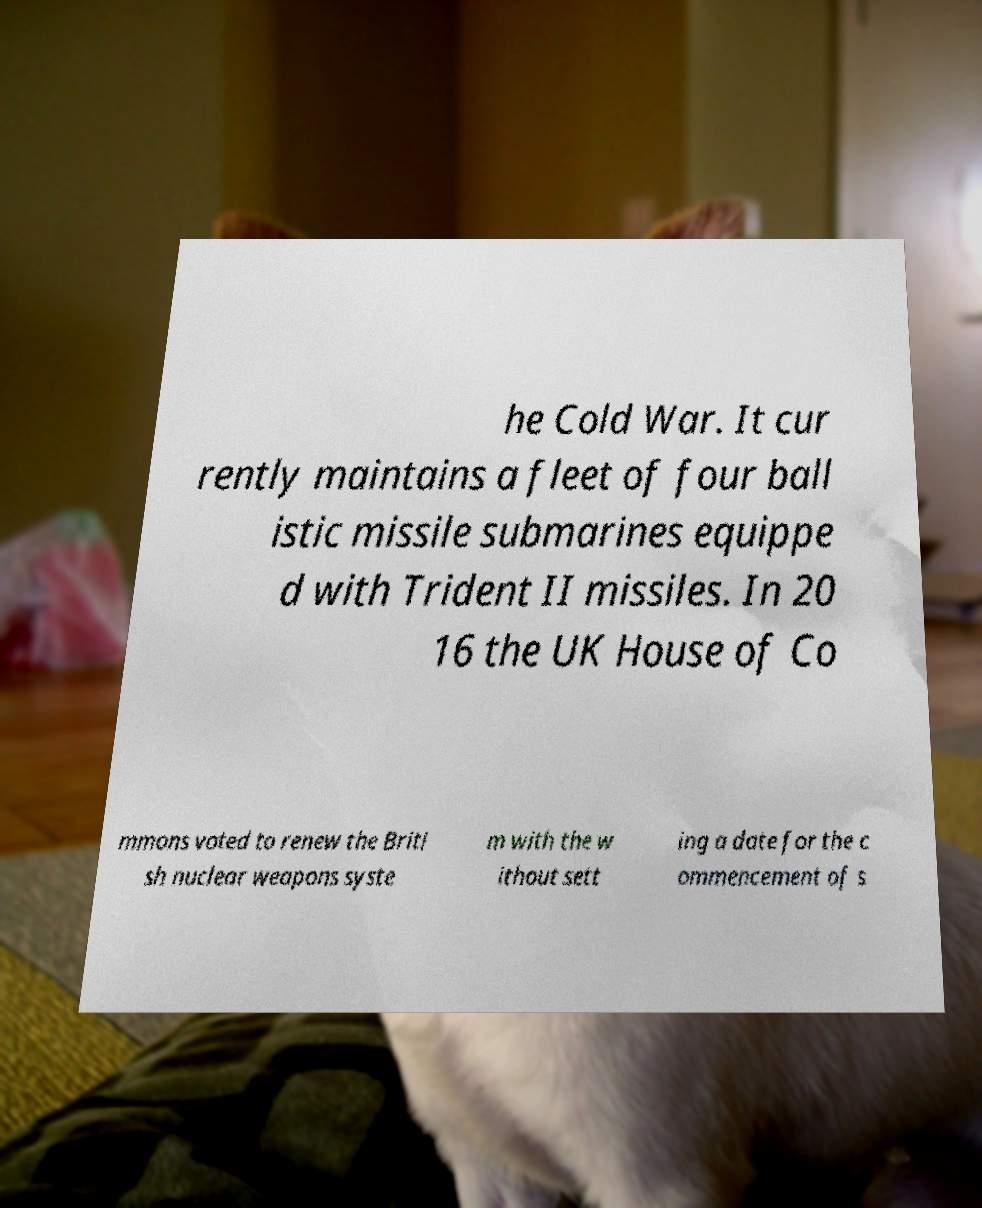Can you read and provide the text displayed in the image?This photo seems to have some interesting text. Can you extract and type it out for me? he Cold War. It cur rently maintains a fleet of four ball istic missile submarines equippe d with Trident II missiles. In 20 16 the UK House of Co mmons voted to renew the Briti sh nuclear weapons syste m with the w ithout sett ing a date for the c ommencement of s 